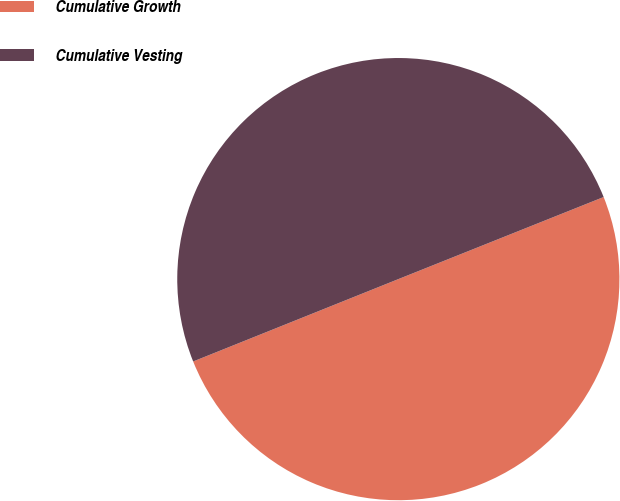<chart> <loc_0><loc_0><loc_500><loc_500><pie_chart><fcel>Cumulative Growth<fcel>Cumulative Vesting<nl><fcel>49.98%<fcel>50.02%<nl></chart> 